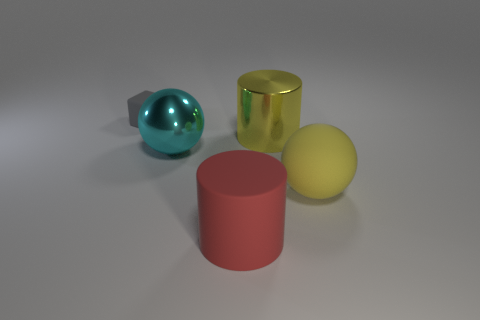Subtract all green balls. Subtract all cyan cylinders. How many balls are left? 2 Add 4 gray cylinders. How many objects exist? 9 Subtract all blocks. How many objects are left? 4 Subtract all rubber cylinders. Subtract all gray matte objects. How many objects are left? 3 Add 3 tiny cubes. How many tiny cubes are left? 4 Add 1 blue metallic things. How many blue metallic things exist? 1 Subtract 0 cyan cylinders. How many objects are left? 5 